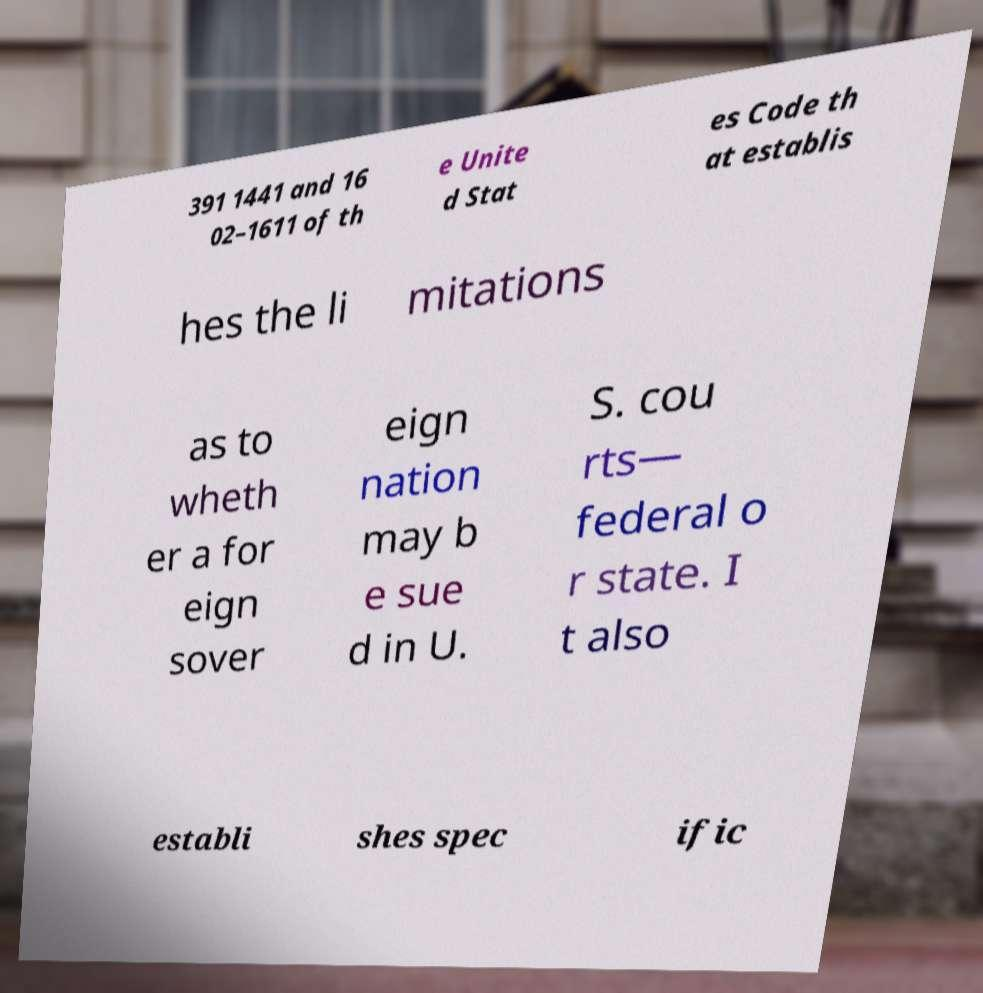Could you extract and type out the text from this image? 391 1441 and 16 02–1611 of th e Unite d Stat es Code th at establis hes the li mitations as to wheth er a for eign sover eign nation may b e sue d in U. S. cou rts— federal o r state. I t also establi shes spec ific 